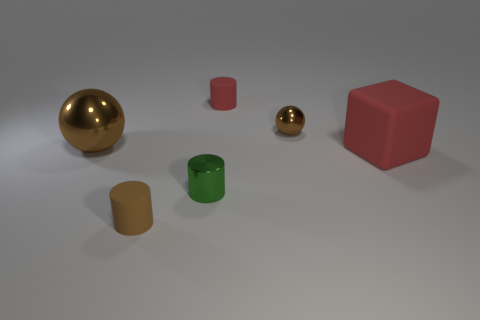Subtract all spheres. How many objects are left? 4 Subtract all green cylinders. How many cylinders are left? 2 Subtract 0 purple balls. How many objects are left? 6 Subtract 1 blocks. How many blocks are left? 0 Subtract all gray cubes. Subtract all cyan cylinders. How many cubes are left? 1 Subtract all green spheres. How many brown cylinders are left? 1 Subtract all red cylinders. Subtract all tiny balls. How many objects are left? 4 Add 6 brown rubber things. How many brown rubber things are left? 7 Add 6 green objects. How many green objects exist? 7 Add 1 large balls. How many objects exist? 7 